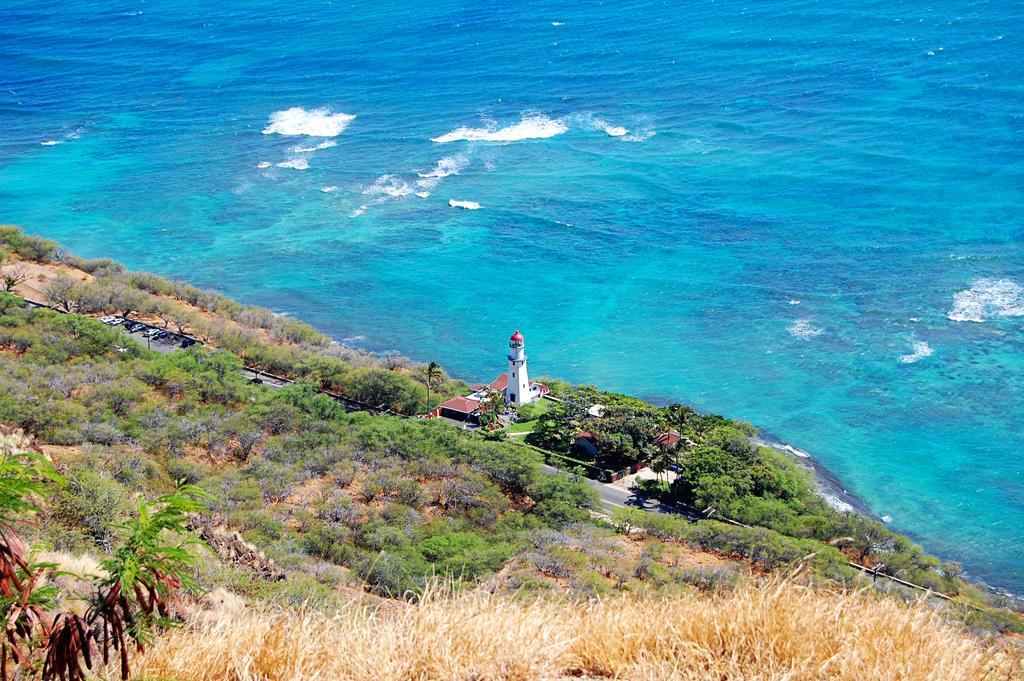Describe this image in one or two sentences. There are trees and plants. Also there is a road. Near to the road there are few buildings. And there is water. Also there is a tower. 